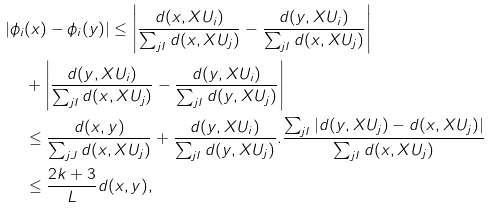Convert formula to latex. <formula><loc_0><loc_0><loc_500><loc_500>| \phi _ { i } & ( x ) - \phi _ { i } ( y ) | \leq \left | \frac { d ( x , X U _ { i } ) } { \sum _ { j I } d ( x , X U _ { j } ) } - \frac { d ( y , X U _ { i } ) } { \sum _ { j I } d ( x , X U _ { j } ) } \right | \\ & + \left | \frac { d ( y , X U _ { i } ) } { \sum _ { j I } d ( x , X U _ { j } ) } - \frac { d ( y , X U _ { i } ) } { \sum _ { j I } d ( y , X U _ { j } ) } \right | \\ & \leq \frac { d ( x , y ) } { \sum _ { j J } d ( x , X U _ { j } ) } + \frac { d ( y , X U _ { i } ) } { \sum _ { j I } d ( y , X U _ { j } ) } . \frac { \sum _ { j I } | d ( y , X U _ { j } ) - d ( x , X U _ { j } ) | } { \sum _ { j I } d ( x , X U _ { j } ) } \\ & \leq \frac { 2 k + 3 } { L } d ( x , y ) ,</formula> 